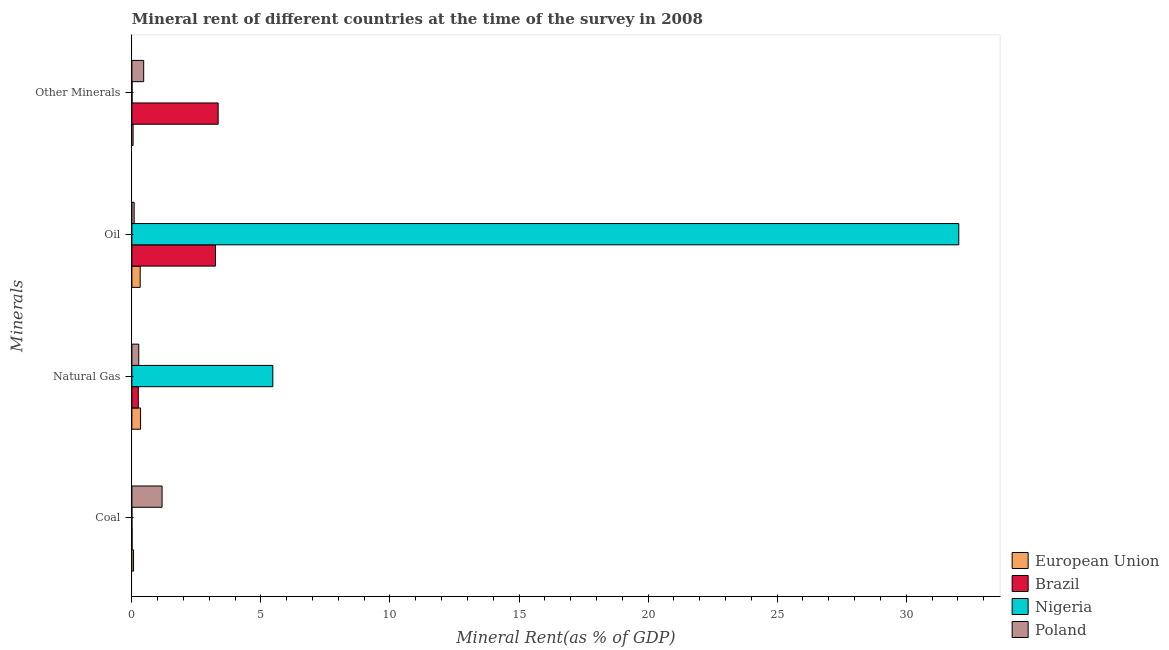Are the number of bars on each tick of the Y-axis equal?
Offer a very short reply. Yes. How many bars are there on the 1st tick from the top?
Ensure brevity in your answer.  4. How many bars are there on the 4th tick from the bottom?
Offer a terse response. 4. What is the label of the 3rd group of bars from the top?
Offer a very short reply. Natural Gas. What is the  rent of other minerals in European Union?
Offer a terse response. 0.05. Across all countries, what is the maximum coal rent?
Offer a very short reply. 1.17. Across all countries, what is the minimum  rent of other minerals?
Provide a succinct answer. 0.01. In which country was the coal rent minimum?
Keep it short and to the point. Nigeria. What is the total coal rent in the graph?
Offer a very short reply. 1.24. What is the difference between the  rent of other minerals in European Union and that in Nigeria?
Ensure brevity in your answer.  0.04. What is the difference between the natural gas rent in Nigeria and the oil rent in Brazil?
Offer a terse response. 2.22. What is the average natural gas rent per country?
Provide a succinct answer. 1.58. What is the difference between the natural gas rent and coal rent in Nigeria?
Give a very brief answer. 5.46. What is the ratio of the  rent of other minerals in Nigeria to that in Brazil?
Your answer should be compact. 0. Is the  rent of other minerals in European Union less than that in Poland?
Offer a very short reply. Yes. Is the difference between the natural gas rent in Nigeria and Brazil greater than the difference between the coal rent in Nigeria and Brazil?
Provide a short and direct response. Yes. What is the difference between the highest and the second highest  rent of other minerals?
Ensure brevity in your answer.  2.88. What is the difference between the highest and the lowest oil rent?
Offer a very short reply. 31.95. Is the sum of the natural gas rent in Poland and European Union greater than the maximum  rent of other minerals across all countries?
Offer a very short reply. No. Is it the case that in every country, the sum of the oil rent and natural gas rent is greater than the sum of  rent of other minerals and coal rent?
Make the answer very short. Yes. What does the 1st bar from the bottom in Oil represents?
Your answer should be compact. European Union. How many bars are there?
Provide a short and direct response. 16. Are all the bars in the graph horizontal?
Offer a terse response. Yes. How are the legend labels stacked?
Your answer should be very brief. Vertical. What is the title of the graph?
Your answer should be compact. Mineral rent of different countries at the time of the survey in 2008. Does "North America" appear as one of the legend labels in the graph?
Give a very brief answer. No. What is the label or title of the X-axis?
Your answer should be very brief. Mineral Rent(as % of GDP). What is the label or title of the Y-axis?
Provide a succinct answer. Minerals. What is the Mineral Rent(as % of GDP) of European Union in Coal?
Provide a succinct answer. 0.07. What is the Mineral Rent(as % of GDP) of Brazil in Coal?
Provide a succinct answer. 0.01. What is the Mineral Rent(as % of GDP) in Nigeria in Coal?
Your answer should be compact. 0. What is the Mineral Rent(as % of GDP) of Poland in Coal?
Keep it short and to the point. 1.17. What is the Mineral Rent(as % of GDP) of European Union in Natural Gas?
Provide a succinct answer. 0.34. What is the Mineral Rent(as % of GDP) in Brazil in Natural Gas?
Offer a very short reply. 0.25. What is the Mineral Rent(as % of GDP) of Nigeria in Natural Gas?
Give a very brief answer. 5.46. What is the Mineral Rent(as % of GDP) in Poland in Natural Gas?
Ensure brevity in your answer.  0.27. What is the Mineral Rent(as % of GDP) of European Union in Oil?
Your answer should be compact. 0.32. What is the Mineral Rent(as % of GDP) in Brazil in Oil?
Provide a short and direct response. 3.24. What is the Mineral Rent(as % of GDP) of Nigeria in Oil?
Ensure brevity in your answer.  32.04. What is the Mineral Rent(as % of GDP) of Poland in Oil?
Offer a terse response. 0.09. What is the Mineral Rent(as % of GDP) of European Union in Other Minerals?
Provide a succinct answer. 0.05. What is the Mineral Rent(as % of GDP) of Brazil in Other Minerals?
Ensure brevity in your answer.  3.34. What is the Mineral Rent(as % of GDP) in Nigeria in Other Minerals?
Your response must be concise. 0.01. What is the Mineral Rent(as % of GDP) in Poland in Other Minerals?
Give a very brief answer. 0.46. Across all Minerals, what is the maximum Mineral Rent(as % of GDP) in European Union?
Offer a very short reply. 0.34. Across all Minerals, what is the maximum Mineral Rent(as % of GDP) of Brazil?
Provide a succinct answer. 3.34. Across all Minerals, what is the maximum Mineral Rent(as % of GDP) of Nigeria?
Ensure brevity in your answer.  32.04. Across all Minerals, what is the maximum Mineral Rent(as % of GDP) of Poland?
Provide a short and direct response. 1.17. Across all Minerals, what is the minimum Mineral Rent(as % of GDP) of European Union?
Provide a short and direct response. 0.05. Across all Minerals, what is the minimum Mineral Rent(as % of GDP) of Brazil?
Offer a terse response. 0.01. Across all Minerals, what is the minimum Mineral Rent(as % of GDP) in Nigeria?
Provide a succinct answer. 0. Across all Minerals, what is the minimum Mineral Rent(as % of GDP) in Poland?
Provide a short and direct response. 0.09. What is the total Mineral Rent(as % of GDP) in European Union in the graph?
Keep it short and to the point. 0.77. What is the total Mineral Rent(as % of GDP) in Brazil in the graph?
Offer a terse response. 6.84. What is the total Mineral Rent(as % of GDP) in Nigeria in the graph?
Give a very brief answer. 37.51. What is the total Mineral Rent(as % of GDP) of Poland in the graph?
Provide a short and direct response. 1.98. What is the difference between the Mineral Rent(as % of GDP) of European Union in Coal and that in Natural Gas?
Make the answer very short. -0.27. What is the difference between the Mineral Rent(as % of GDP) of Brazil in Coal and that in Natural Gas?
Give a very brief answer. -0.24. What is the difference between the Mineral Rent(as % of GDP) of Nigeria in Coal and that in Natural Gas?
Make the answer very short. -5.46. What is the difference between the Mineral Rent(as % of GDP) in Poland in Coal and that in Natural Gas?
Provide a succinct answer. 0.9. What is the difference between the Mineral Rent(as % of GDP) in European Union in Coal and that in Oil?
Offer a very short reply. -0.26. What is the difference between the Mineral Rent(as % of GDP) in Brazil in Coal and that in Oil?
Provide a short and direct response. -3.23. What is the difference between the Mineral Rent(as % of GDP) in Nigeria in Coal and that in Oil?
Give a very brief answer. -32.04. What is the difference between the Mineral Rent(as % of GDP) of Poland in Coal and that in Oil?
Ensure brevity in your answer.  1.08. What is the difference between the Mineral Rent(as % of GDP) of European Union in Coal and that in Other Minerals?
Provide a short and direct response. 0.02. What is the difference between the Mineral Rent(as % of GDP) of Brazil in Coal and that in Other Minerals?
Provide a succinct answer. -3.33. What is the difference between the Mineral Rent(as % of GDP) of Nigeria in Coal and that in Other Minerals?
Provide a succinct answer. -0. What is the difference between the Mineral Rent(as % of GDP) in Poland in Coal and that in Other Minerals?
Your response must be concise. 0.71. What is the difference between the Mineral Rent(as % of GDP) in European Union in Natural Gas and that in Oil?
Ensure brevity in your answer.  0.01. What is the difference between the Mineral Rent(as % of GDP) in Brazil in Natural Gas and that in Oil?
Provide a short and direct response. -2.99. What is the difference between the Mineral Rent(as % of GDP) in Nigeria in Natural Gas and that in Oil?
Your answer should be very brief. -26.58. What is the difference between the Mineral Rent(as % of GDP) of Poland in Natural Gas and that in Oil?
Provide a short and direct response. 0.18. What is the difference between the Mineral Rent(as % of GDP) of European Union in Natural Gas and that in Other Minerals?
Offer a very short reply. 0.29. What is the difference between the Mineral Rent(as % of GDP) in Brazil in Natural Gas and that in Other Minerals?
Offer a very short reply. -3.09. What is the difference between the Mineral Rent(as % of GDP) in Nigeria in Natural Gas and that in Other Minerals?
Offer a very short reply. 5.45. What is the difference between the Mineral Rent(as % of GDP) of Poland in Natural Gas and that in Other Minerals?
Your answer should be very brief. -0.19. What is the difference between the Mineral Rent(as % of GDP) in European Union in Oil and that in Other Minerals?
Make the answer very short. 0.28. What is the difference between the Mineral Rent(as % of GDP) of Brazil in Oil and that in Other Minerals?
Ensure brevity in your answer.  -0.1. What is the difference between the Mineral Rent(as % of GDP) in Nigeria in Oil and that in Other Minerals?
Make the answer very short. 32.03. What is the difference between the Mineral Rent(as % of GDP) of Poland in Oil and that in Other Minerals?
Keep it short and to the point. -0.37. What is the difference between the Mineral Rent(as % of GDP) in European Union in Coal and the Mineral Rent(as % of GDP) in Brazil in Natural Gas?
Offer a very short reply. -0.18. What is the difference between the Mineral Rent(as % of GDP) in European Union in Coal and the Mineral Rent(as % of GDP) in Nigeria in Natural Gas?
Offer a terse response. -5.4. What is the difference between the Mineral Rent(as % of GDP) in European Union in Coal and the Mineral Rent(as % of GDP) in Poland in Natural Gas?
Make the answer very short. -0.2. What is the difference between the Mineral Rent(as % of GDP) of Brazil in Coal and the Mineral Rent(as % of GDP) of Nigeria in Natural Gas?
Provide a short and direct response. -5.45. What is the difference between the Mineral Rent(as % of GDP) of Brazil in Coal and the Mineral Rent(as % of GDP) of Poland in Natural Gas?
Provide a short and direct response. -0.26. What is the difference between the Mineral Rent(as % of GDP) of Nigeria in Coal and the Mineral Rent(as % of GDP) of Poland in Natural Gas?
Your answer should be compact. -0.27. What is the difference between the Mineral Rent(as % of GDP) of European Union in Coal and the Mineral Rent(as % of GDP) of Brazil in Oil?
Ensure brevity in your answer.  -3.17. What is the difference between the Mineral Rent(as % of GDP) of European Union in Coal and the Mineral Rent(as % of GDP) of Nigeria in Oil?
Ensure brevity in your answer.  -31.97. What is the difference between the Mineral Rent(as % of GDP) of European Union in Coal and the Mineral Rent(as % of GDP) of Poland in Oil?
Ensure brevity in your answer.  -0.02. What is the difference between the Mineral Rent(as % of GDP) of Brazil in Coal and the Mineral Rent(as % of GDP) of Nigeria in Oil?
Give a very brief answer. -32.03. What is the difference between the Mineral Rent(as % of GDP) of Brazil in Coal and the Mineral Rent(as % of GDP) of Poland in Oil?
Ensure brevity in your answer.  -0.08. What is the difference between the Mineral Rent(as % of GDP) of Nigeria in Coal and the Mineral Rent(as % of GDP) of Poland in Oil?
Give a very brief answer. -0.09. What is the difference between the Mineral Rent(as % of GDP) of European Union in Coal and the Mineral Rent(as % of GDP) of Brazil in Other Minerals?
Give a very brief answer. -3.28. What is the difference between the Mineral Rent(as % of GDP) in European Union in Coal and the Mineral Rent(as % of GDP) in Nigeria in Other Minerals?
Provide a short and direct response. 0.06. What is the difference between the Mineral Rent(as % of GDP) in European Union in Coal and the Mineral Rent(as % of GDP) in Poland in Other Minerals?
Your response must be concise. -0.39. What is the difference between the Mineral Rent(as % of GDP) of Brazil in Coal and the Mineral Rent(as % of GDP) of Nigeria in Other Minerals?
Offer a very short reply. 0. What is the difference between the Mineral Rent(as % of GDP) in Brazil in Coal and the Mineral Rent(as % of GDP) in Poland in Other Minerals?
Provide a succinct answer. -0.45. What is the difference between the Mineral Rent(as % of GDP) of Nigeria in Coal and the Mineral Rent(as % of GDP) of Poland in Other Minerals?
Give a very brief answer. -0.46. What is the difference between the Mineral Rent(as % of GDP) of European Union in Natural Gas and the Mineral Rent(as % of GDP) of Brazil in Oil?
Make the answer very short. -2.9. What is the difference between the Mineral Rent(as % of GDP) in European Union in Natural Gas and the Mineral Rent(as % of GDP) in Nigeria in Oil?
Offer a terse response. -31.7. What is the difference between the Mineral Rent(as % of GDP) in European Union in Natural Gas and the Mineral Rent(as % of GDP) in Poland in Oil?
Provide a short and direct response. 0.25. What is the difference between the Mineral Rent(as % of GDP) of Brazil in Natural Gas and the Mineral Rent(as % of GDP) of Nigeria in Oil?
Offer a very short reply. -31.79. What is the difference between the Mineral Rent(as % of GDP) in Brazil in Natural Gas and the Mineral Rent(as % of GDP) in Poland in Oil?
Provide a short and direct response. 0.16. What is the difference between the Mineral Rent(as % of GDP) of Nigeria in Natural Gas and the Mineral Rent(as % of GDP) of Poland in Oil?
Your response must be concise. 5.37. What is the difference between the Mineral Rent(as % of GDP) in European Union in Natural Gas and the Mineral Rent(as % of GDP) in Brazil in Other Minerals?
Provide a succinct answer. -3.01. What is the difference between the Mineral Rent(as % of GDP) of European Union in Natural Gas and the Mineral Rent(as % of GDP) of Nigeria in Other Minerals?
Ensure brevity in your answer.  0.33. What is the difference between the Mineral Rent(as % of GDP) in European Union in Natural Gas and the Mineral Rent(as % of GDP) in Poland in Other Minerals?
Keep it short and to the point. -0.12. What is the difference between the Mineral Rent(as % of GDP) of Brazil in Natural Gas and the Mineral Rent(as % of GDP) of Nigeria in Other Minerals?
Provide a short and direct response. 0.24. What is the difference between the Mineral Rent(as % of GDP) in Brazil in Natural Gas and the Mineral Rent(as % of GDP) in Poland in Other Minerals?
Your answer should be very brief. -0.21. What is the difference between the Mineral Rent(as % of GDP) of Nigeria in Natural Gas and the Mineral Rent(as % of GDP) of Poland in Other Minerals?
Offer a terse response. 5. What is the difference between the Mineral Rent(as % of GDP) of European Union in Oil and the Mineral Rent(as % of GDP) of Brazil in Other Minerals?
Offer a very short reply. -3.02. What is the difference between the Mineral Rent(as % of GDP) in European Union in Oil and the Mineral Rent(as % of GDP) in Nigeria in Other Minerals?
Keep it short and to the point. 0.32. What is the difference between the Mineral Rent(as % of GDP) of European Union in Oil and the Mineral Rent(as % of GDP) of Poland in Other Minerals?
Give a very brief answer. -0.14. What is the difference between the Mineral Rent(as % of GDP) in Brazil in Oil and the Mineral Rent(as % of GDP) in Nigeria in Other Minerals?
Make the answer very short. 3.23. What is the difference between the Mineral Rent(as % of GDP) in Brazil in Oil and the Mineral Rent(as % of GDP) in Poland in Other Minerals?
Provide a short and direct response. 2.78. What is the difference between the Mineral Rent(as % of GDP) of Nigeria in Oil and the Mineral Rent(as % of GDP) of Poland in Other Minerals?
Your answer should be very brief. 31.58. What is the average Mineral Rent(as % of GDP) in European Union per Minerals?
Make the answer very short. 0.19. What is the average Mineral Rent(as % of GDP) of Brazil per Minerals?
Give a very brief answer. 1.71. What is the average Mineral Rent(as % of GDP) of Nigeria per Minerals?
Give a very brief answer. 9.38. What is the average Mineral Rent(as % of GDP) in Poland per Minerals?
Your answer should be compact. 0.5. What is the difference between the Mineral Rent(as % of GDP) in European Union and Mineral Rent(as % of GDP) in Brazil in Coal?
Ensure brevity in your answer.  0.06. What is the difference between the Mineral Rent(as % of GDP) in European Union and Mineral Rent(as % of GDP) in Nigeria in Coal?
Keep it short and to the point. 0.06. What is the difference between the Mineral Rent(as % of GDP) in European Union and Mineral Rent(as % of GDP) in Poland in Coal?
Your answer should be very brief. -1.1. What is the difference between the Mineral Rent(as % of GDP) of Brazil and Mineral Rent(as % of GDP) of Nigeria in Coal?
Provide a succinct answer. 0.01. What is the difference between the Mineral Rent(as % of GDP) of Brazil and Mineral Rent(as % of GDP) of Poland in Coal?
Ensure brevity in your answer.  -1.16. What is the difference between the Mineral Rent(as % of GDP) of Nigeria and Mineral Rent(as % of GDP) of Poland in Coal?
Keep it short and to the point. -1.17. What is the difference between the Mineral Rent(as % of GDP) in European Union and Mineral Rent(as % of GDP) in Brazil in Natural Gas?
Keep it short and to the point. 0.09. What is the difference between the Mineral Rent(as % of GDP) of European Union and Mineral Rent(as % of GDP) of Nigeria in Natural Gas?
Your answer should be compact. -5.12. What is the difference between the Mineral Rent(as % of GDP) of European Union and Mineral Rent(as % of GDP) of Poland in Natural Gas?
Give a very brief answer. 0.07. What is the difference between the Mineral Rent(as % of GDP) of Brazil and Mineral Rent(as % of GDP) of Nigeria in Natural Gas?
Your answer should be very brief. -5.21. What is the difference between the Mineral Rent(as % of GDP) in Brazil and Mineral Rent(as % of GDP) in Poland in Natural Gas?
Ensure brevity in your answer.  -0.02. What is the difference between the Mineral Rent(as % of GDP) in Nigeria and Mineral Rent(as % of GDP) in Poland in Natural Gas?
Make the answer very short. 5.19. What is the difference between the Mineral Rent(as % of GDP) in European Union and Mineral Rent(as % of GDP) in Brazil in Oil?
Your answer should be compact. -2.92. What is the difference between the Mineral Rent(as % of GDP) in European Union and Mineral Rent(as % of GDP) in Nigeria in Oil?
Ensure brevity in your answer.  -31.72. What is the difference between the Mineral Rent(as % of GDP) of European Union and Mineral Rent(as % of GDP) of Poland in Oil?
Your answer should be very brief. 0.23. What is the difference between the Mineral Rent(as % of GDP) of Brazil and Mineral Rent(as % of GDP) of Nigeria in Oil?
Your response must be concise. -28.8. What is the difference between the Mineral Rent(as % of GDP) in Brazil and Mineral Rent(as % of GDP) in Poland in Oil?
Your response must be concise. 3.15. What is the difference between the Mineral Rent(as % of GDP) in Nigeria and Mineral Rent(as % of GDP) in Poland in Oil?
Provide a short and direct response. 31.95. What is the difference between the Mineral Rent(as % of GDP) of European Union and Mineral Rent(as % of GDP) of Brazil in Other Minerals?
Provide a succinct answer. -3.3. What is the difference between the Mineral Rent(as % of GDP) of European Union and Mineral Rent(as % of GDP) of Nigeria in Other Minerals?
Keep it short and to the point. 0.04. What is the difference between the Mineral Rent(as % of GDP) in European Union and Mineral Rent(as % of GDP) in Poland in Other Minerals?
Make the answer very short. -0.41. What is the difference between the Mineral Rent(as % of GDP) in Brazil and Mineral Rent(as % of GDP) in Nigeria in Other Minerals?
Ensure brevity in your answer.  3.34. What is the difference between the Mineral Rent(as % of GDP) of Brazil and Mineral Rent(as % of GDP) of Poland in Other Minerals?
Give a very brief answer. 2.88. What is the difference between the Mineral Rent(as % of GDP) of Nigeria and Mineral Rent(as % of GDP) of Poland in Other Minerals?
Provide a short and direct response. -0.45. What is the ratio of the Mineral Rent(as % of GDP) of European Union in Coal to that in Natural Gas?
Your answer should be very brief. 0.19. What is the ratio of the Mineral Rent(as % of GDP) in Brazil in Coal to that in Natural Gas?
Ensure brevity in your answer.  0.03. What is the ratio of the Mineral Rent(as % of GDP) of Nigeria in Coal to that in Natural Gas?
Your answer should be very brief. 0. What is the ratio of the Mineral Rent(as % of GDP) in Poland in Coal to that in Natural Gas?
Make the answer very short. 4.38. What is the ratio of the Mineral Rent(as % of GDP) of European Union in Coal to that in Oil?
Your answer should be very brief. 0.2. What is the ratio of the Mineral Rent(as % of GDP) of Brazil in Coal to that in Oil?
Provide a succinct answer. 0. What is the ratio of the Mineral Rent(as % of GDP) in Poland in Coal to that in Oil?
Your answer should be very brief. 13.3. What is the ratio of the Mineral Rent(as % of GDP) in European Union in Coal to that in Other Minerals?
Give a very brief answer. 1.39. What is the ratio of the Mineral Rent(as % of GDP) of Brazil in Coal to that in Other Minerals?
Your response must be concise. 0. What is the ratio of the Mineral Rent(as % of GDP) of Nigeria in Coal to that in Other Minerals?
Provide a succinct answer. 0.2. What is the ratio of the Mineral Rent(as % of GDP) of Poland in Coal to that in Other Minerals?
Your answer should be compact. 2.56. What is the ratio of the Mineral Rent(as % of GDP) of European Union in Natural Gas to that in Oil?
Keep it short and to the point. 1.04. What is the ratio of the Mineral Rent(as % of GDP) of Brazil in Natural Gas to that in Oil?
Keep it short and to the point. 0.08. What is the ratio of the Mineral Rent(as % of GDP) of Nigeria in Natural Gas to that in Oil?
Give a very brief answer. 0.17. What is the ratio of the Mineral Rent(as % of GDP) of Poland in Natural Gas to that in Oil?
Provide a succinct answer. 3.04. What is the ratio of the Mineral Rent(as % of GDP) of European Union in Natural Gas to that in Other Minerals?
Provide a succinct answer. 7.21. What is the ratio of the Mineral Rent(as % of GDP) in Brazil in Natural Gas to that in Other Minerals?
Keep it short and to the point. 0.07. What is the ratio of the Mineral Rent(as % of GDP) in Nigeria in Natural Gas to that in Other Minerals?
Your response must be concise. 898.42. What is the ratio of the Mineral Rent(as % of GDP) in Poland in Natural Gas to that in Other Minerals?
Ensure brevity in your answer.  0.58. What is the ratio of the Mineral Rent(as % of GDP) in European Union in Oil to that in Other Minerals?
Your answer should be very brief. 6.9. What is the ratio of the Mineral Rent(as % of GDP) in Brazil in Oil to that in Other Minerals?
Your response must be concise. 0.97. What is the ratio of the Mineral Rent(as % of GDP) in Nigeria in Oil to that in Other Minerals?
Ensure brevity in your answer.  5271.2. What is the ratio of the Mineral Rent(as % of GDP) of Poland in Oil to that in Other Minerals?
Your answer should be compact. 0.19. What is the difference between the highest and the second highest Mineral Rent(as % of GDP) in European Union?
Your answer should be very brief. 0.01. What is the difference between the highest and the second highest Mineral Rent(as % of GDP) of Brazil?
Your response must be concise. 0.1. What is the difference between the highest and the second highest Mineral Rent(as % of GDP) of Nigeria?
Keep it short and to the point. 26.58. What is the difference between the highest and the second highest Mineral Rent(as % of GDP) of Poland?
Ensure brevity in your answer.  0.71. What is the difference between the highest and the lowest Mineral Rent(as % of GDP) of European Union?
Give a very brief answer. 0.29. What is the difference between the highest and the lowest Mineral Rent(as % of GDP) in Brazil?
Provide a short and direct response. 3.33. What is the difference between the highest and the lowest Mineral Rent(as % of GDP) of Nigeria?
Offer a terse response. 32.04. What is the difference between the highest and the lowest Mineral Rent(as % of GDP) of Poland?
Provide a succinct answer. 1.08. 